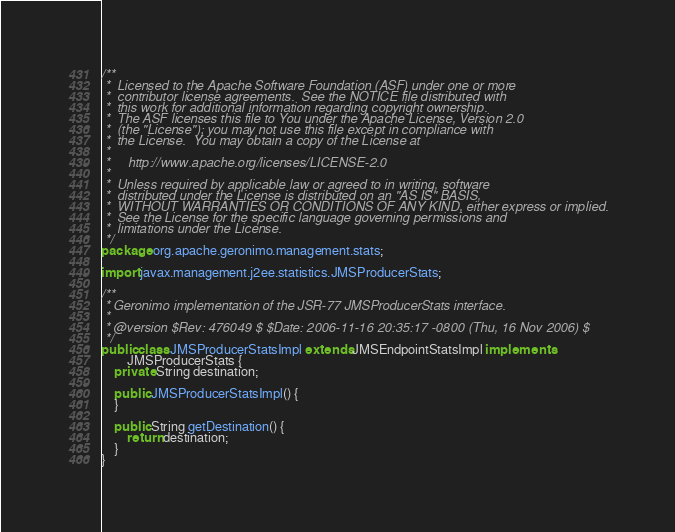Convert code to text. <code><loc_0><loc_0><loc_500><loc_500><_Java_>/**
 *  Licensed to the Apache Software Foundation (ASF) under one or more
 *  contributor license agreements.  See the NOTICE file distributed with
 *  this work for additional information regarding copyright ownership.
 *  The ASF licenses this file to You under the Apache License, Version 2.0
 *  (the "License"); you may not use this file except in compliance with
 *  the License.  You may obtain a copy of the License at
 *
 *     http://www.apache.org/licenses/LICENSE-2.0
 *
 *  Unless required by applicable law or agreed to in writing, software
 *  distributed under the License is distributed on an "AS IS" BASIS,
 *  WITHOUT WARRANTIES OR CONDITIONS OF ANY KIND, either express or implied.
 *  See the License for the specific language governing permissions and
 *  limitations under the License.
 */
package org.apache.geronimo.management.stats;

import javax.management.j2ee.statistics.JMSProducerStats;

/**
 * Geronimo implementation of the JSR-77 JMSProducerStats interface.
 * 
 * @version $Rev: 476049 $ $Date: 2006-11-16 20:35:17 -0800 (Thu, 16 Nov 2006) $
 */
public class JMSProducerStatsImpl extends JMSEndpointStatsImpl implements
        JMSProducerStats {
    private String destination;

    public JMSProducerStatsImpl() {
    }

    public String getDestination() {
        return destination;
    }
}
</code> 